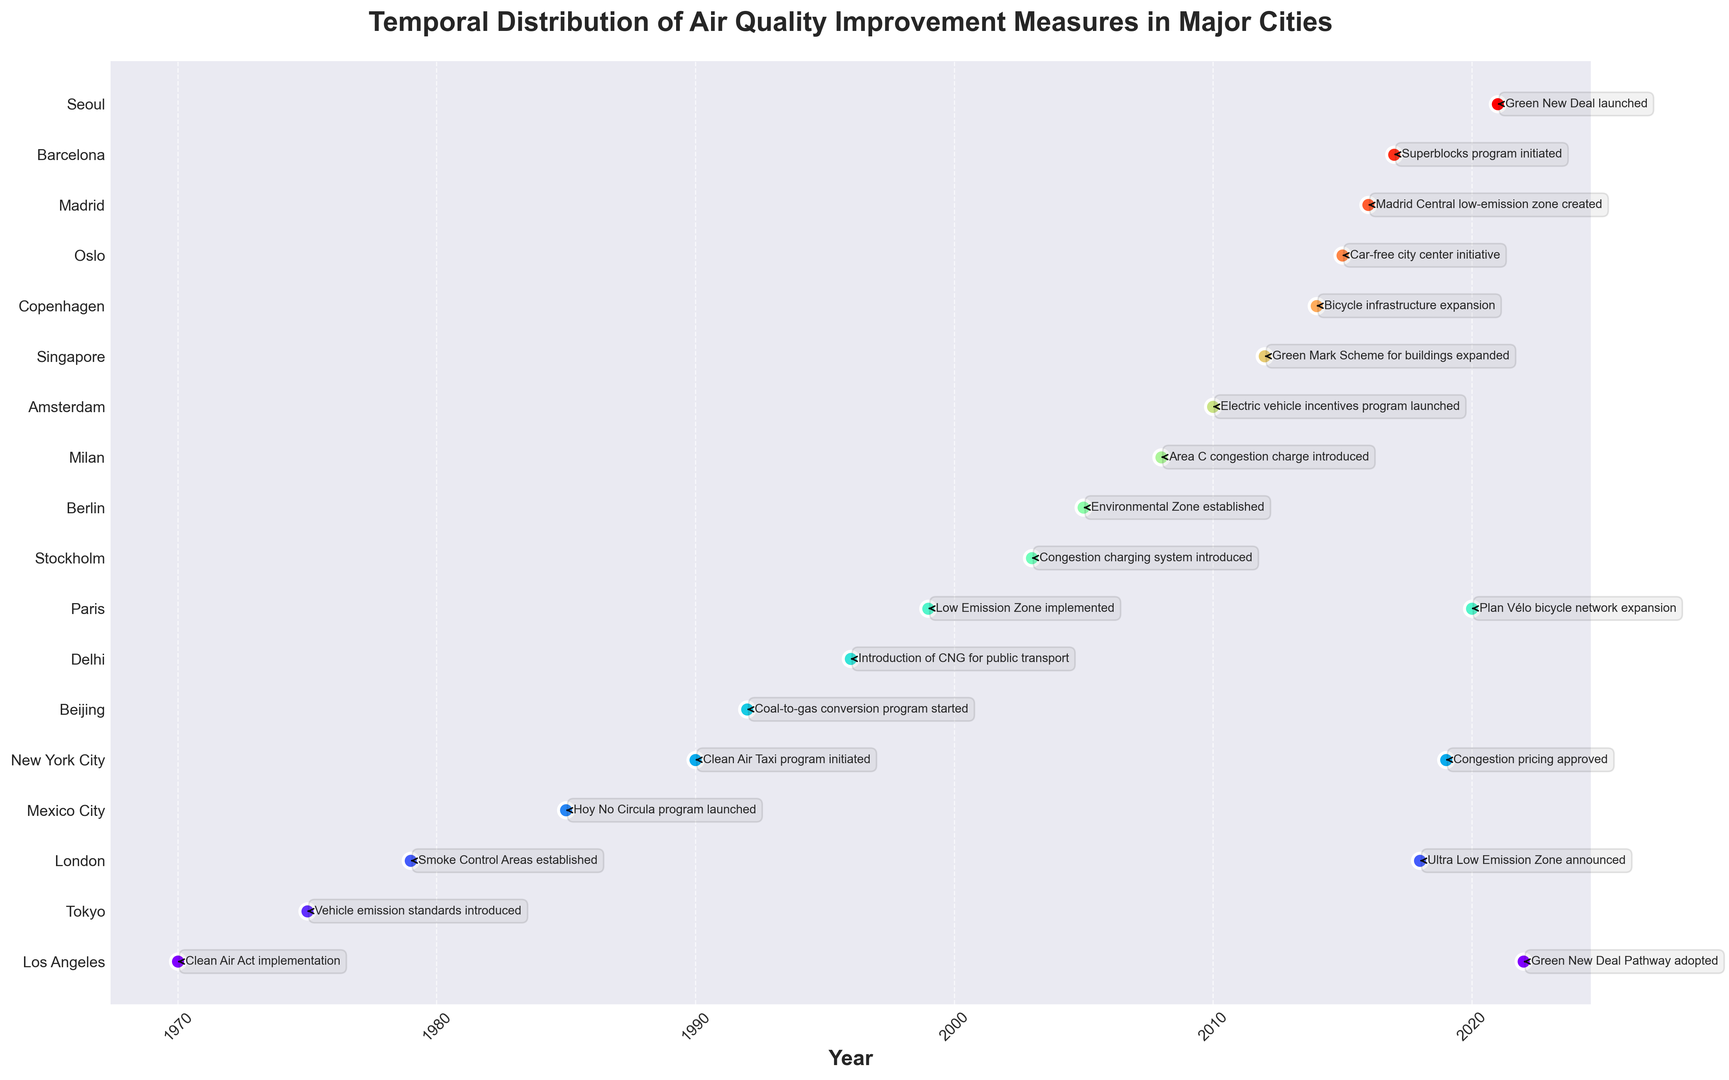Which city implemented the first air quality improvement measure? The figure shows various cities with their respective years of implementing air quality improvements. By identifying the earliest year, we can determine that Los Angeles implemented the first measure in 1970.
Answer: Los Angeles Which city had an air quality improvement measure announced in the most recent year? The figure details measures implemented up to 2022. By identifying the most recent year, we observe that Los Angeles had a measure announced in 2022.
Answer: Los Angeles How many years apart were the measures taken by Tokyo and New York City? Tokyo implemented its measure in 1975, and New York City in 1990. The difference between these years is 1990 - 1975 = 15 years.
Answer: 15 years Which cities implemented air quality measures within the same decade? By categorizing cities based on the decade of implementation, we find that Los Angeles and Tokyo in the 1970s, London and Mexico City in the 1980s, and several other groupings within the subsequent decades implemented measures within the same decade.
Answer: Various pairs (e.g., Los Angeles & Tokyo, London & Mexico City) Identify the city that focused on bicycle infrastructure expansion and the year it happened. The figure shows Copenhagen implementing bicycle infrastructure expansion in 2014. This can be determined by locating Copenhagen and reading the associated year and measure text.
Answer: Copenhagen, 2014 How many cities implemented measures between 1995 and 2005 (inclusive)? We count the number of cities whose measures fall within the range of 1995 and 2005. These include Delhi (1996), Paris (1999), Stockholm (2003), and Berlin (2005). Thus, there are 4 cities.
Answer: 4 cities Which city introduced a congestion pricing system first, and in what year? Comparing the entries for congestion pricing systems in Stockholm (2003), Milan (2008), and New York City (2019), we determine that Stockholm introduced it first in 2003.
Answer: Stockholm, 2003 Which city implemented both a low-emission zone and a congestion charge? By examining the measures, we find Paris implemented a Low Emission Zone in 1999 and also had an "Area C" congestion charge introduced in Milan in 2008 (Note: if the figure indicates separate instances, specify accordingly).
Answer: Paris What is the average year of implementation for all the air quality measures? Summing all the years and dividing by the total number of measures (22), the calculation is (1970 + 1975 + 1979 + 1985 + 1990 + 1992 + 1996 + 1999 + 2003 + 2005 + 2008 + 2010 + 2012 + 2014 + 2015 + 2016 + 2017 + 2018 + 2019 + 2020 + 2021 + 2022) / 22 = 1995.18.
Answer: 1995.18 